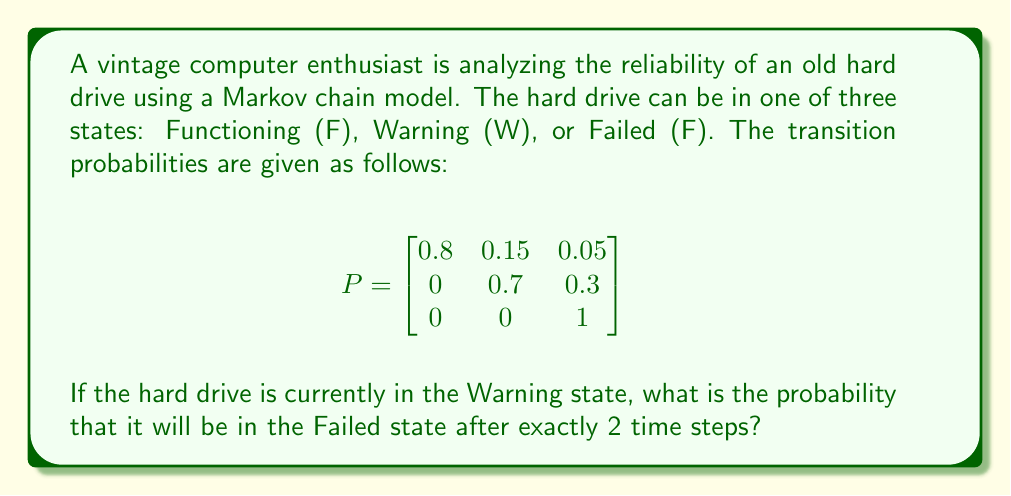Provide a solution to this math problem. To solve this problem, we need to use the Chapman-Kolmogorov equations and calculate the 2-step transition probability.

Step 1: Identify the initial state and target state.
Initial state: Warning (W)
Target state: Failed (F)

Step 2: Calculate the 2-step transition probability matrix by squaring the given transition matrix.

$$P^2 = P \times P = \begin{bmatrix}
0.8 & 0.15 & 0.05 \\
0 & 0.7 & 0.3 \\
0 & 0 & 1
\end{bmatrix} \times \begin{bmatrix}
0.8 & 0.15 & 0.05 \\
0 & 0.7 & 0.3 \\
0 & 0 & 1
\end{bmatrix}$$

Step 3: Perform the matrix multiplication.

$$P^2 = \begin{bmatrix}
0.64 & 0.245 & 0.115 \\
0 & 0.49 & 0.51 \\
0 & 0 & 1
\end{bmatrix}$$

Step 4: Identify the probability of transitioning from Warning (W) to Failed (F) in 2 steps.
This probability is found in the second row (W) and third column (F) of the $P^2$ matrix.

Probability(W to F in 2 steps) = 0.51

Therefore, the probability that the hard drive will be in the Failed state after exactly 2 time steps, given that it starts in the Warning state, is 0.51 or 51%.
Answer: 0.51 